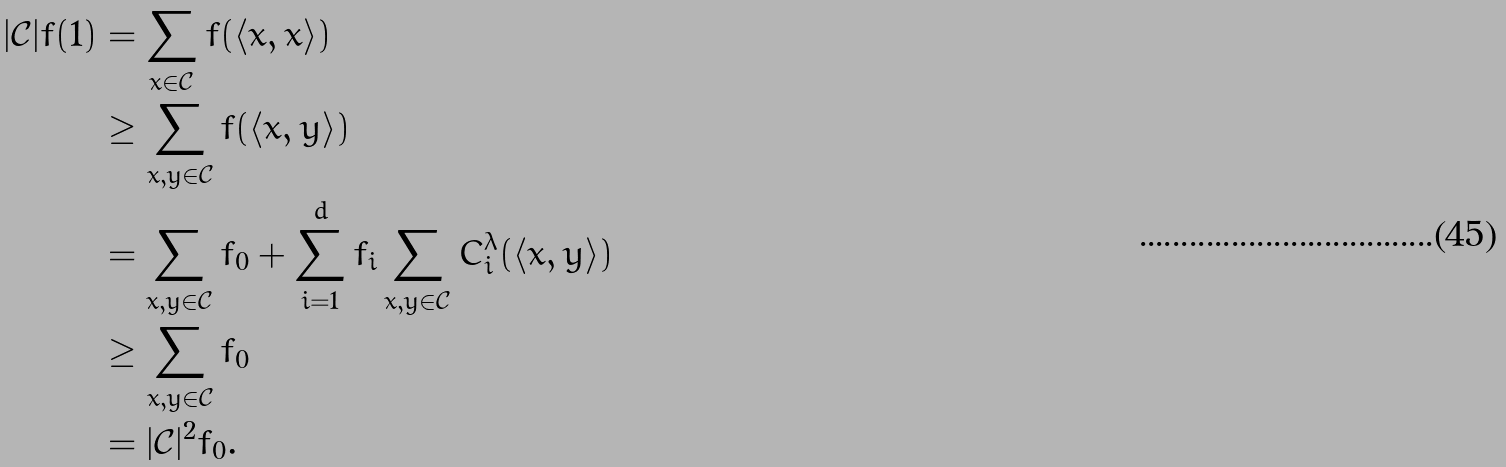Convert formula to latex. <formula><loc_0><loc_0><loc_500><loc_500>| \mathcal { C } | f ( 1 ) & = \sum _ { x \in \mathcal { C } } f ( \langle x , x \rangle ) \\ & \geq \sum _ { x , y \in \mathcal { C } } f ( \langle x , y \rangle ) \\ & = \sum _ { x , y \in \mathcal { C } } f _ { 0 } + \sum _ { i = 1 } ^ { d } f _ { i } \sum _ { x , y \in \mathcal { C } } C _ { i } ^ { \lambda } ( \langle x , y \rangle ) \\ & \geq \sum _ { x , y \in \mathcal { C } } f _ { 0 } \\ & = | \mathcal { C } | ^ { 2 } f _ { 0 } .</formula> 